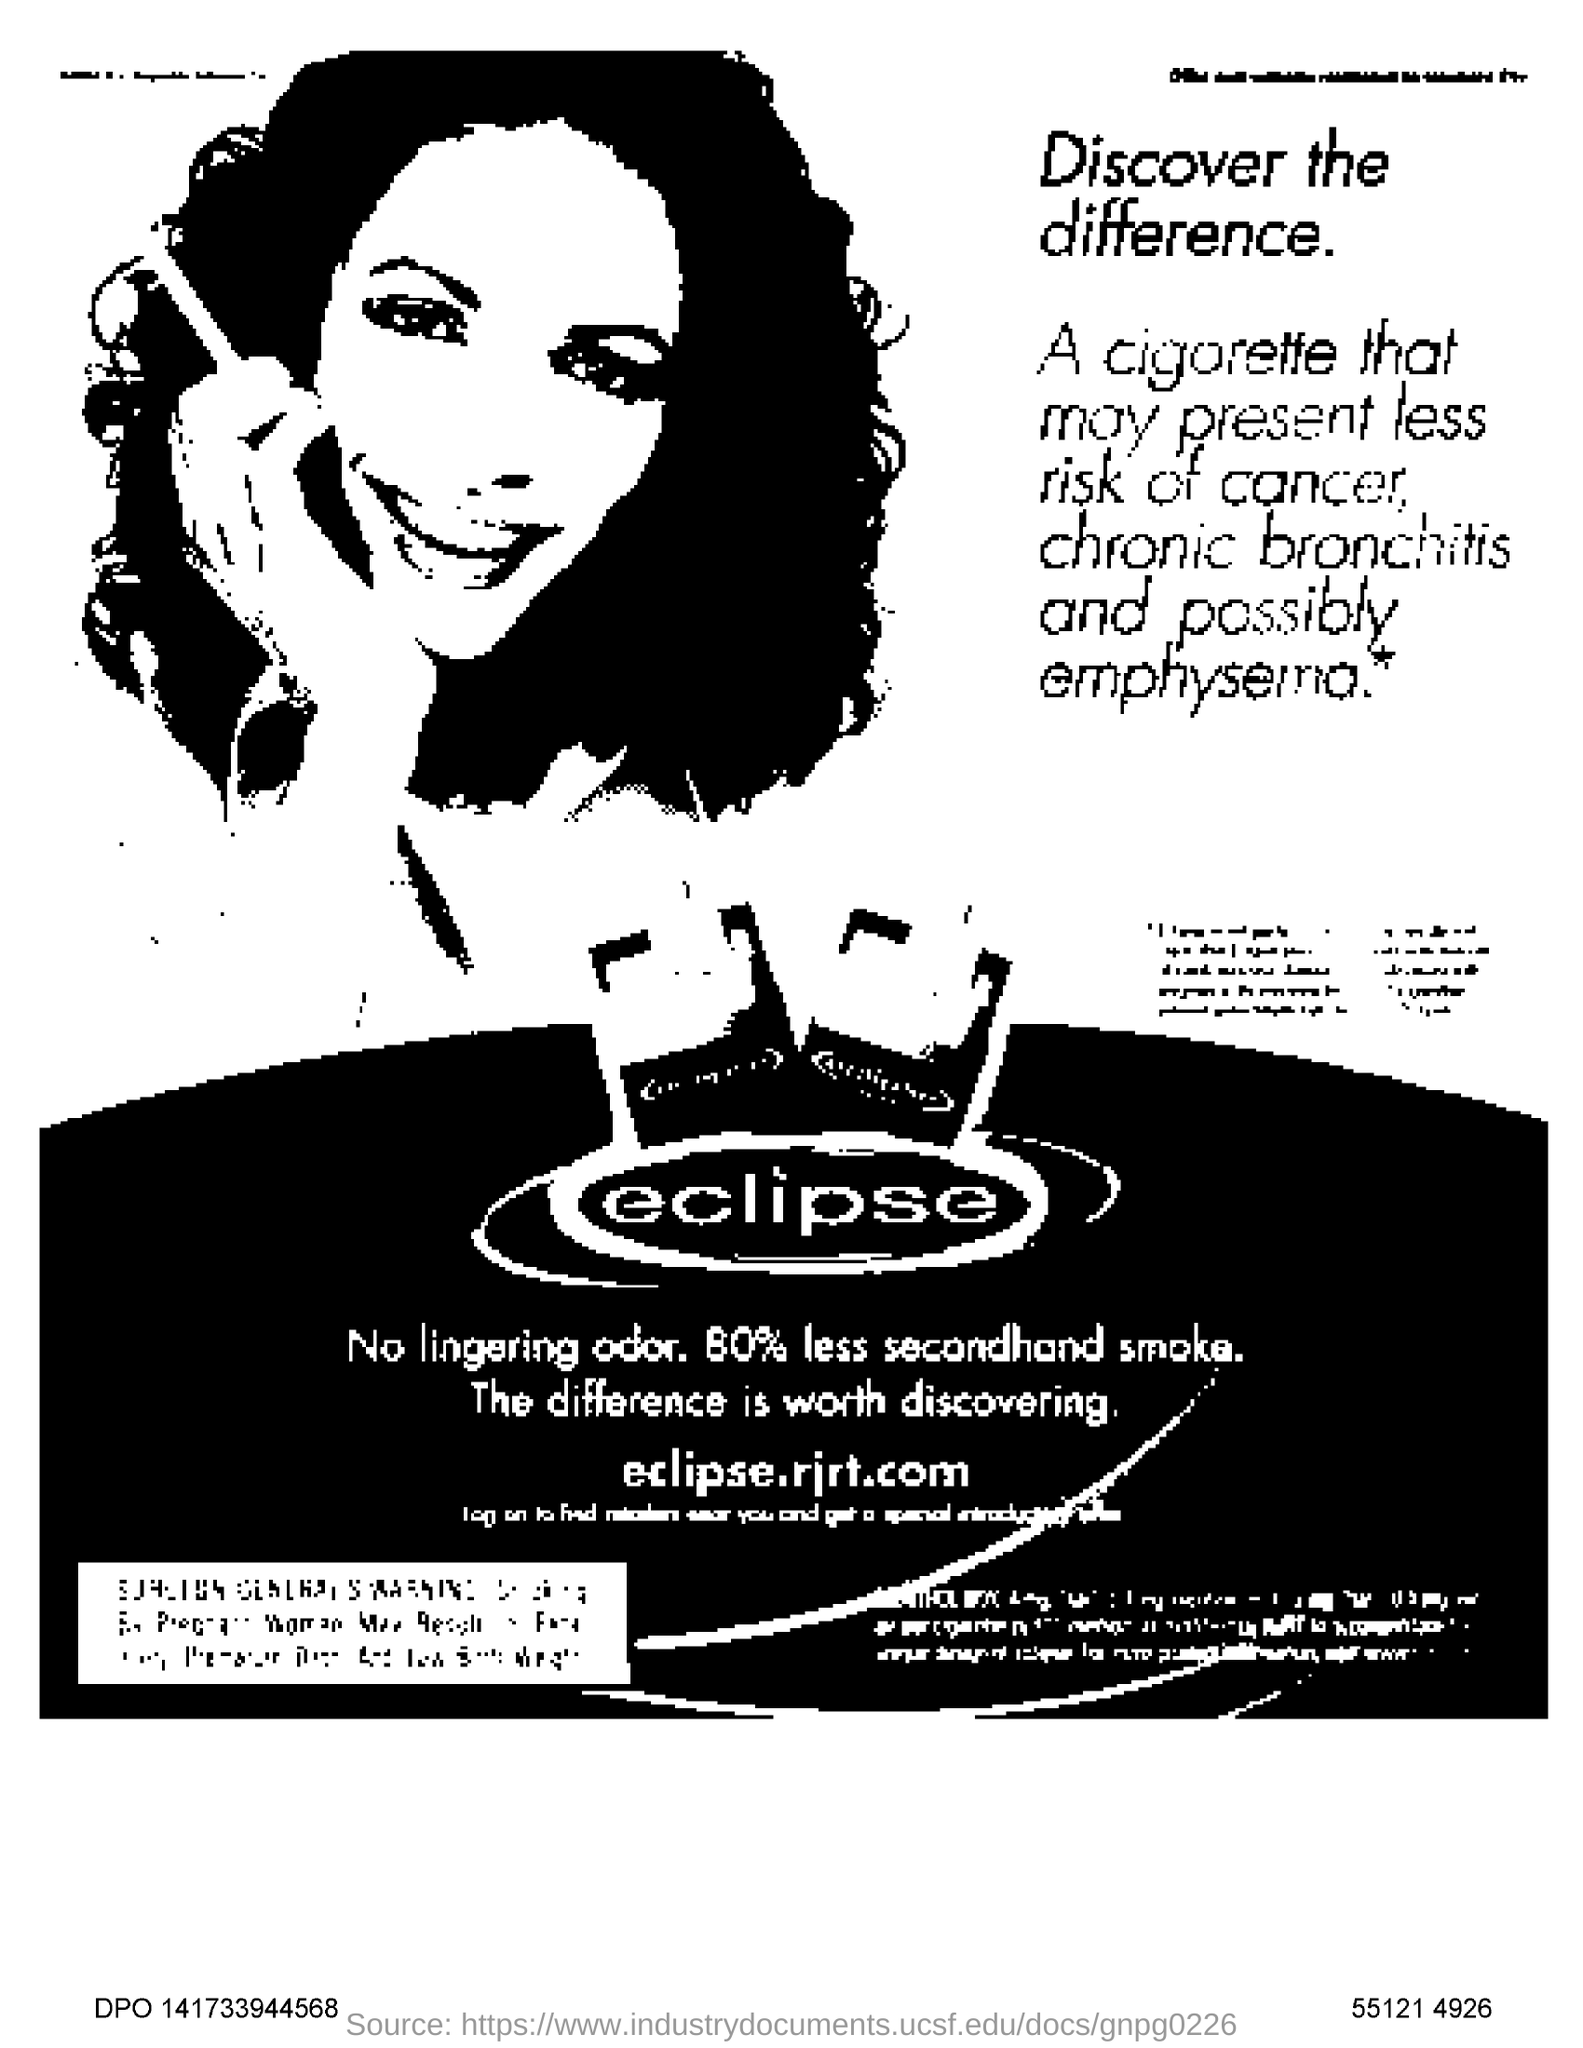Which company is the advertisement for?
Give a very brief answer. Eclipse. What is the website listed in the advertisement?
Make the answer very short. Eclipse.rjrt.com. 